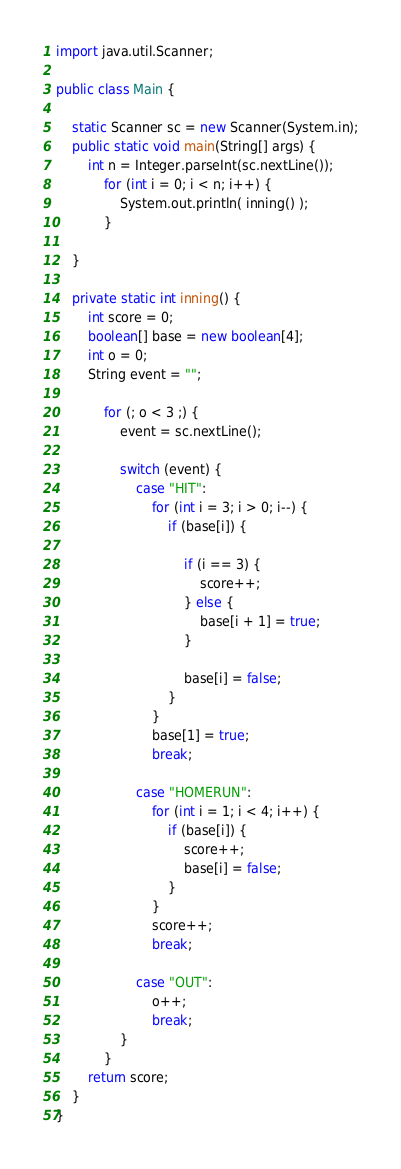Convert code to text. <code><loc_0><loc_0><loc_500><loc_500><_Java_>import java.util.Scanner;

public class Main {

	static Scanner sc = new Scanner(System.in);
	public static void main(String[] args) {
		int n = Integer.parseInt(sc.nextLine());
			for (int i = 0; i < n; i++) {
				System.out.println( inning() );
			}

	}

	private static int inning() {
		int score = 0;
		boolean[] base = new boolean[4];
		int o = 0;
		String event = "";

			for (; o < 3 ;) {
				event = sc.nextLine();

				switch (event) {
					case "HIT":
						for (int i = 3; i > 0; i--) {
							if (base[i]) {

								if (i == 3) {
									score++;
								} else {
									base[i + 1] = true;
								}

								base[i] = false;
							}
						}
						base[1] = true;
						break;

					case "HOMERUN":
						for (int i = 1; i < 4; i++) {
							if (base[i]) {
								score++;
								base[i] = false;
							}
						}
						score++;
						break;

					case "OUT":
						o++;
						break;
				}
			}
		return score;
	}
}

</code> 